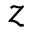<formula> <loc_0><loc_0><loc_500><loc_500>z</formula> 